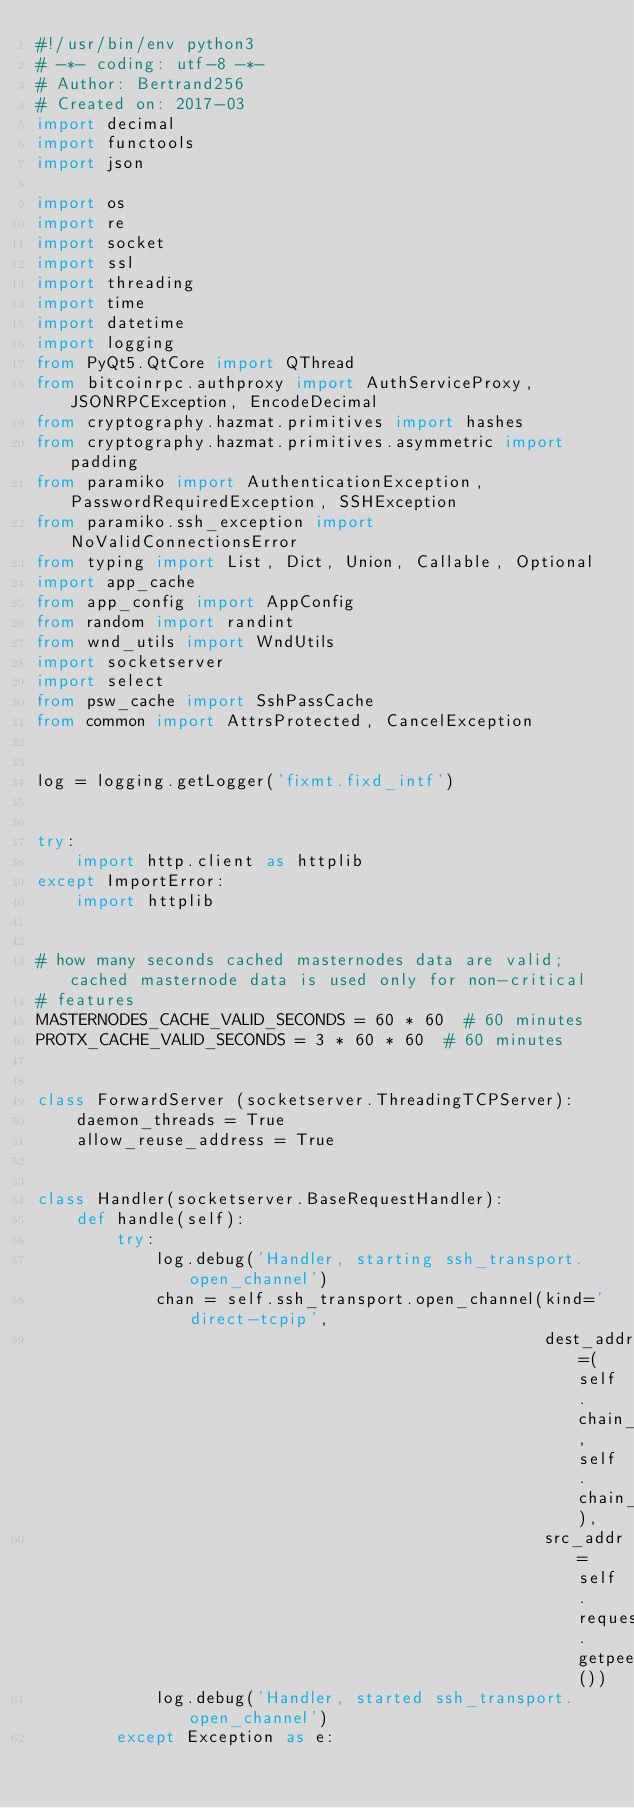Convert code to text. <code><loc_0><loc_0><loc_500><loc_500><_Python_>#!/usr/bin/env python3
# -*- coding: utf-8 -*-
# Author: Bertrand256
# Created on: 2017-03
import decimal
import functools
import json

import os
import re
import socket
import ssl
import threading
import time
import datetime
import logging
from PyQt5.QtCore import QThread
from bitcoinrpc.authproxy import AuthServiceProxy, JSONRPCException, EncodeDecimal
from cryptography.hazmat.primitives import hashes
from cryptography.hazmat.primitives.asymmetric import padding
from paramiko import AuthenticationException, PasswordRequiredException, SSHException
from paramiko.ssh_exception import NoValidConnectionsError
from typing import List, Dict, Union, Callable, Optional
import app_cache
from app_config import AppConfig
from random import randint
from wnd_utils import WndUtils
import socketserver
import select
from psw_cache import SshPassCache
from common import AttrsProtected, CancelException


log = logging.getLogger('fixmt.fixd_intf')


try:
    import http.client as httplib
except ImportError:
    import httplib


# how many seconds cached masternodes data are valid; cached masternode data is used only for non-critical
# features
MASTERNODES_CACHE_VALID_SECONDS = 60 * 60  # 60 minutes
PROTX_CACHE_VALID_SECONDS = 3 * 60 * 60  # 60 minutes


class ForwardServer (socketserver.ThreadingTCPServer):
    daemon_threads = True
    allow_reuse_address = True


class Handler(socketserver.BaseRequestHandler):
    def handle(self):
        try:
            log.debug('Handler, starting ssh_transport.open_channel')
            chan = self.ssh_transport.open_channel(kind='direct-tcpip',
                                                   dest_addr=(self.chain_host, self.chain_port),
                                                   src_addr=self.request.getpeername())
            log.debug('Handler, started ssh_transport.open_channel')
        except Exception as e:</code> 